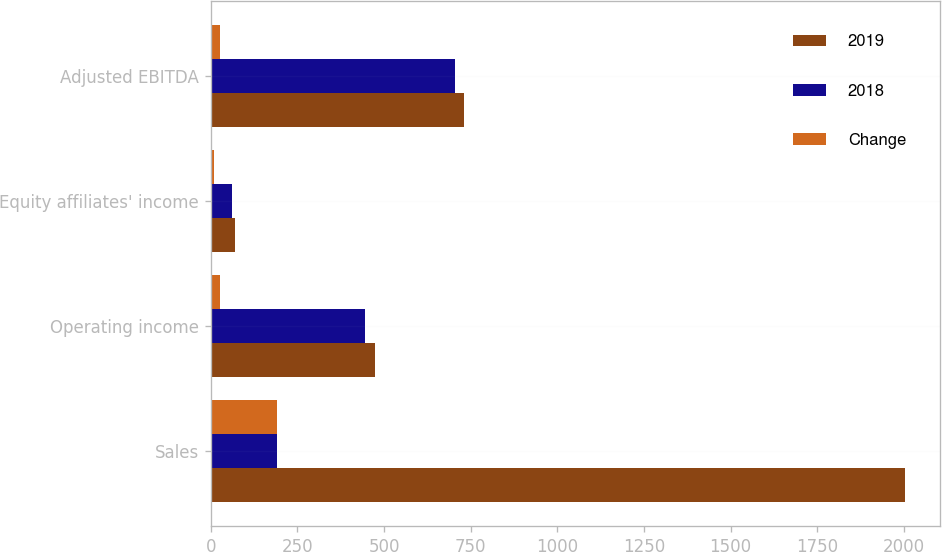Convert chart to OTSL. <chart><loc_0><loc_0><loc_500><loc_500><stacked_bar_chart><ecel><fcel>Sales<fcel>Operating income<fcel>Equity affiliates' income<fcel>Adjusted EBITDA<nl><fcel>2019<fcel>2002.5<fcel>472.4<fcel>69<fcel>730.9<nl><fcel>2018<fcel>190.8<fcel>445.8<fcel>61.1<fcel>705.5<nl><fcel>Change<fcel>190.8<fcel>26.6<fcel>7.9<fcel>25.4<nl></chart> 